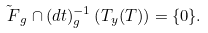Convert formula to latex. <formula><loc_0><loc_0><loc_500><loc_500>\tilde { \ F } _ { g } \cap ( d t ) _ { g } ^ { - 1 } \left ( T _ { y } ( T ) \right ) = \{ 0 \} .</formula> 